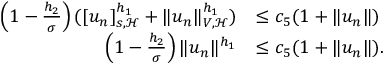Convert formula to latex. <formula><loc_0><loc_0><loc_500><loc_500>\begin{array} { r l } { \left ( 1 - \frac { h _ { 2 } } { \sigma } \right ) ( [ u _ { n } ] _ { s , \mathcal { H } } ^ { h _ { 1 } } + \| u _ { n } \| _ { V , \mathcal { H } } ^ { h _ { 1 } } ) } & { \leq c _ { 5 } ( 1 + \| u _ { n } \| ) } \\ { \left ( 1 - \frac { h _ { 2 } } { \sigma } \right ) \| u _ { n } \| ^ { h _ { 1 } } } & { \leq c _ { 5 } ( 1 + \| u _ { n } \| ) . } \end{array}</formula> 